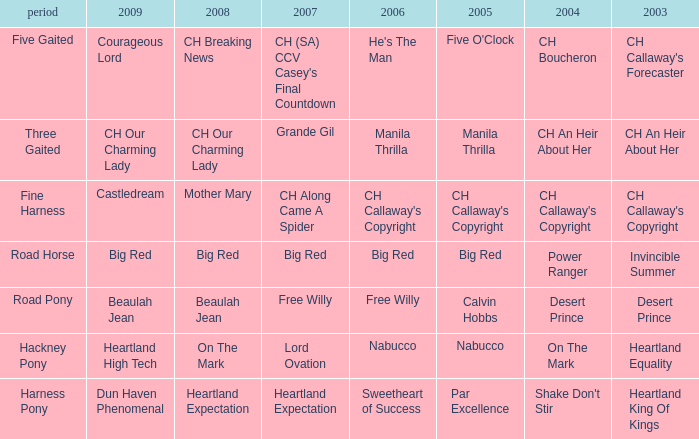What year is the 2007 big red? Road Horse. 